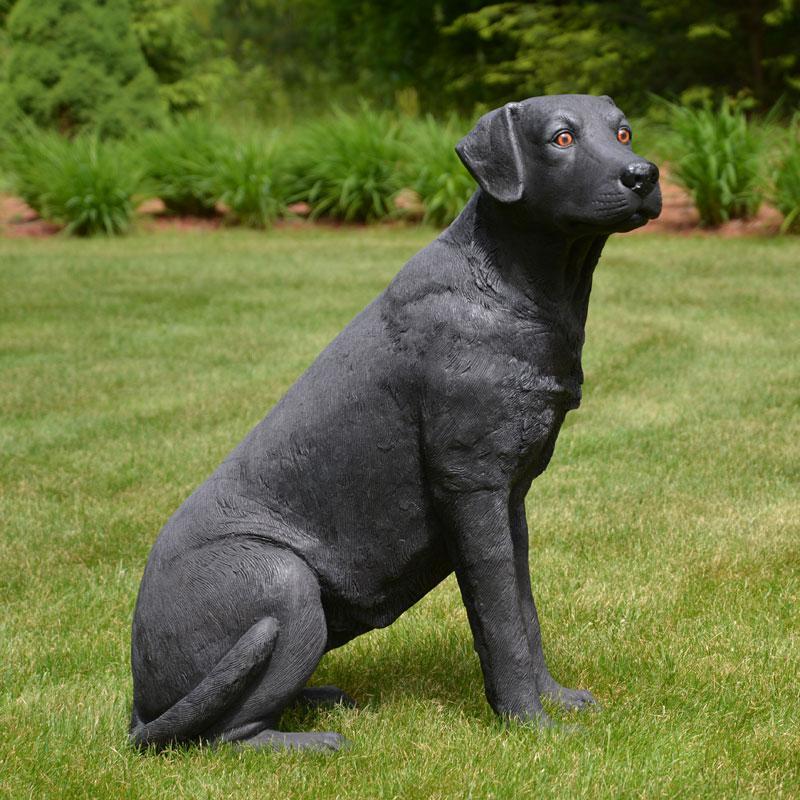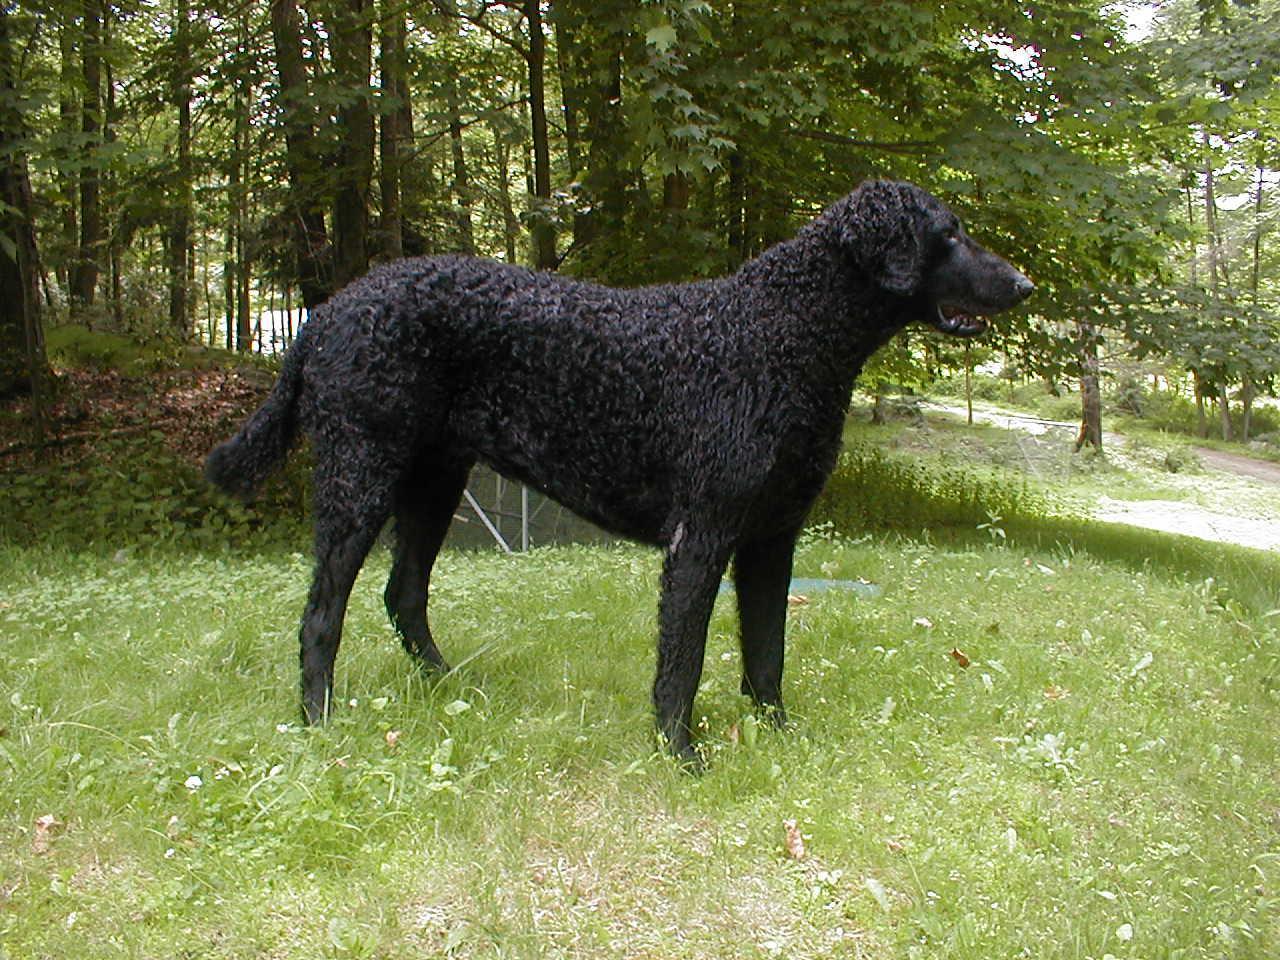The first image is the image on the left, the second image is the image on the right. Assess this claim about the two images: "Only one of the dogs is black.". Correct or not? Answer yes or no. No. 